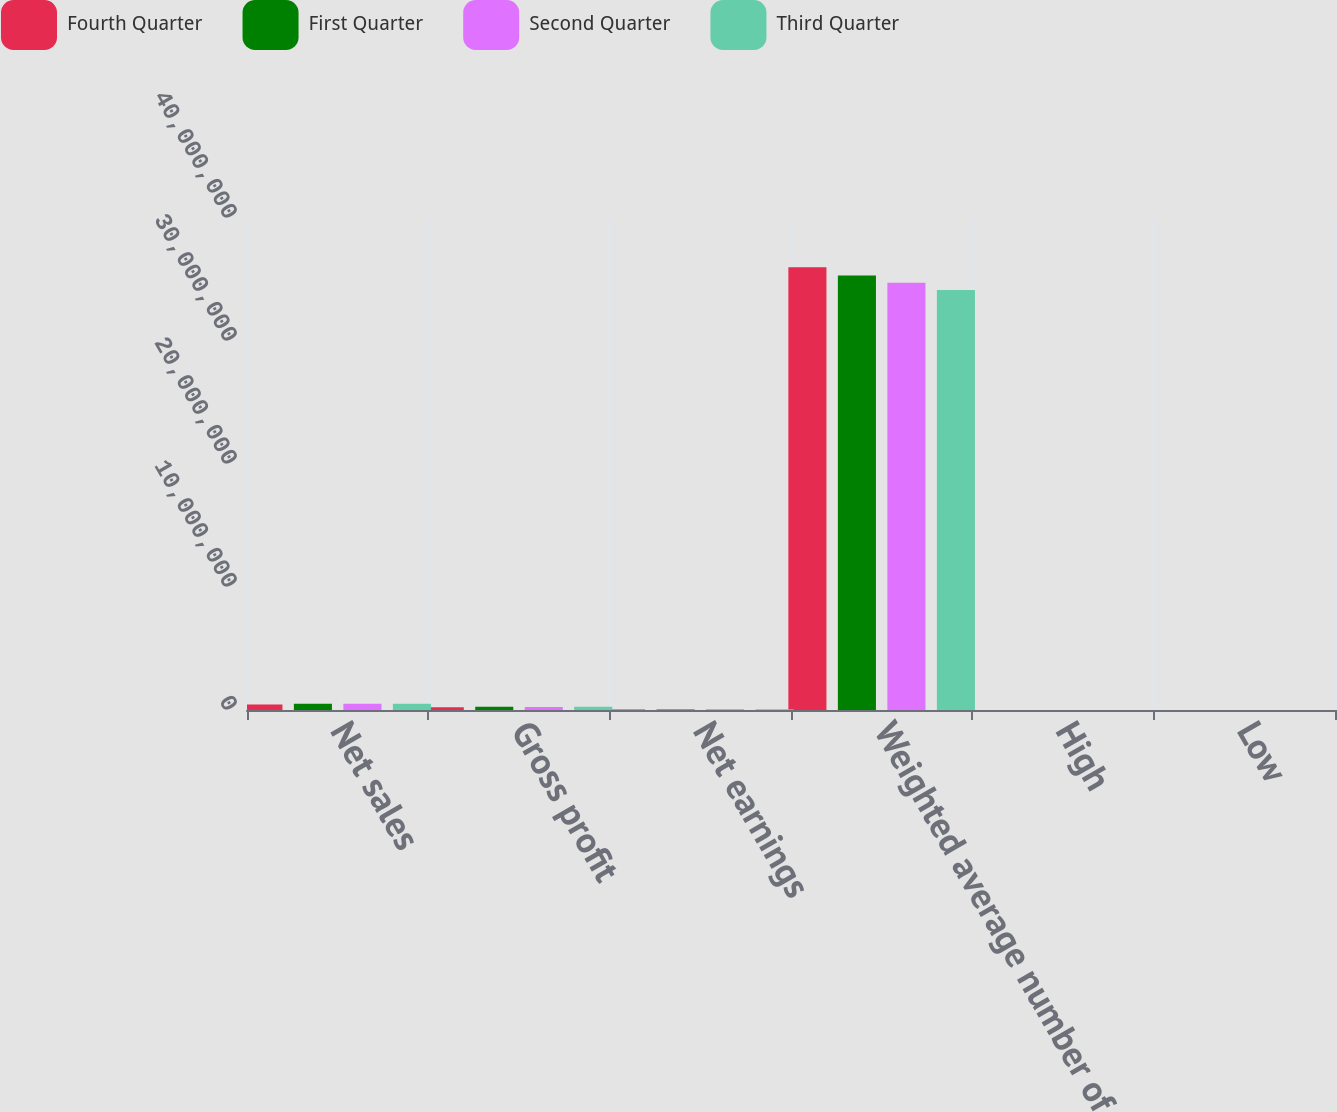Convert chart. <chart><loc_0><loc_0><loc_500><loc_500><stacked_bar_chart><ecel><fcel>Net sales<fcel>Gross profit<fcel>Net earnings<fcel>Weighted average number of<fcel>High<fcel>Low<nl><fcel>Fourth Quarter<fcel>438955<fcel>221152<fcel>38279<fcel>3.59938e+07<fcel>112.37<fcel>87.51<nl><fcel>First Quarter<fcel>515605<fcel>259011<fcel>48851<fcel>3.53208e+07<fcel>105.01<fcel>94.05<nl><fcel>Second Quarter<fcel>509097<fcel>248680<fcel>52724<fcel>3.47278e+07<fcel>109.16<fcel>92.6<nl><fcel>Third Quarter<fcel>509687<fcel>264238<fcel>62924<fcel>3.41531e+07<fcel>98.33<fcel>60.64<nl></chart> 